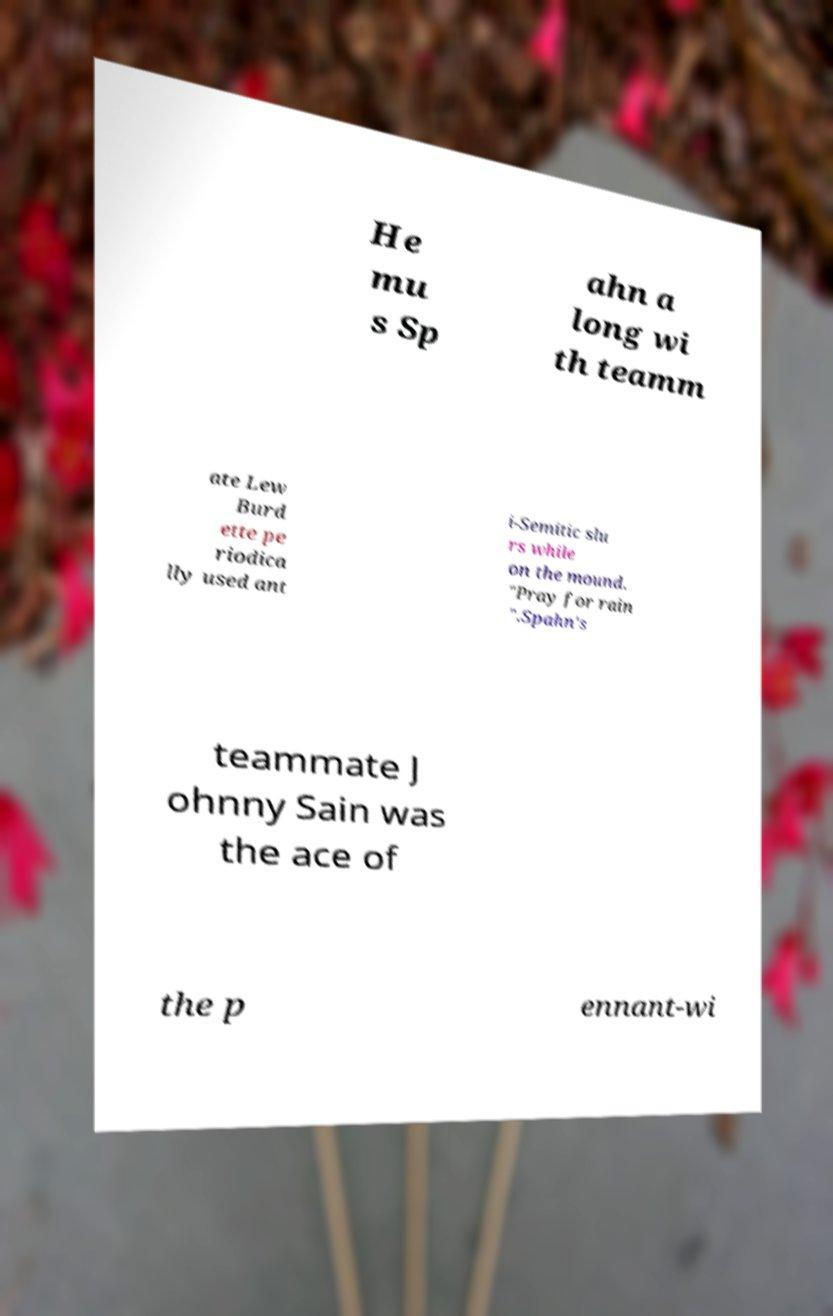What messages or text are displayed in this image? I need them in a readable, typed format. He mu s Sp ahn a long wi th teamm ate Lew Burd ette pe riodica lly used ant i-Semitic slu rs while on the mound. "Pray for rain ".Spahn's teammate J ohnny Sain was the ace of the p ennant-wi 